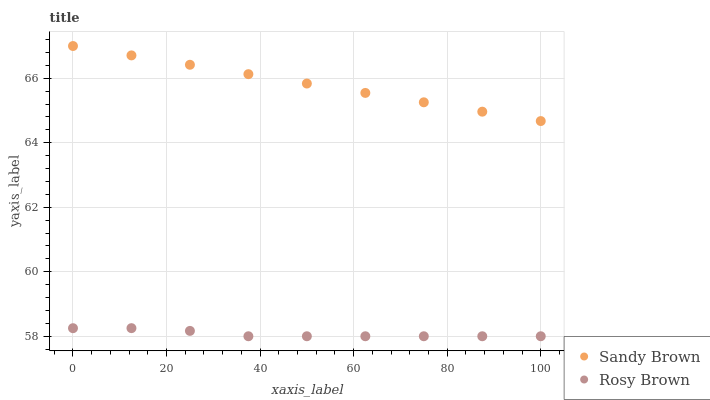Does Rosy Brown have the minimum area under the curve?
Answer yes or no. Yes. Does Sandy Brown have the maximum area under the curve?
Answer yes or no. Yes. Does Sandy Brown have the minimum area under the curve?
Answer yes or no. No. Is Sandy Brown the smoothest?
Answer yes or no. Yes. Is Rosy Brown the roughest?
Answer yes or no. Yes. Is Sandy Brown the roughest?
Answer yes or no. No. Does Rosy Brown have the lowest value?
Answer yes or no. Yes. Does Sandy Brown have the lowest value?
Answer yes or no. No. Does Sandy Brown have the highest value?
Answer yes or no. Yes. Is Rosy Brown less than Sandy Brown?
Answer yes or no. Yes. Is Sandy Brown greater than Rosy Brown?
Answer yes or no. Yes. Does Rosy Brown intersect Sandy Brown?
Answer yes or no. No. 